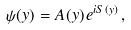Convert formula to latex. <formula><loc_0><loc_0><loc_500><loc_500>\psi ( y ) = A ( y ) \, e ^ { i S ( y ) } \, ,</formula> 